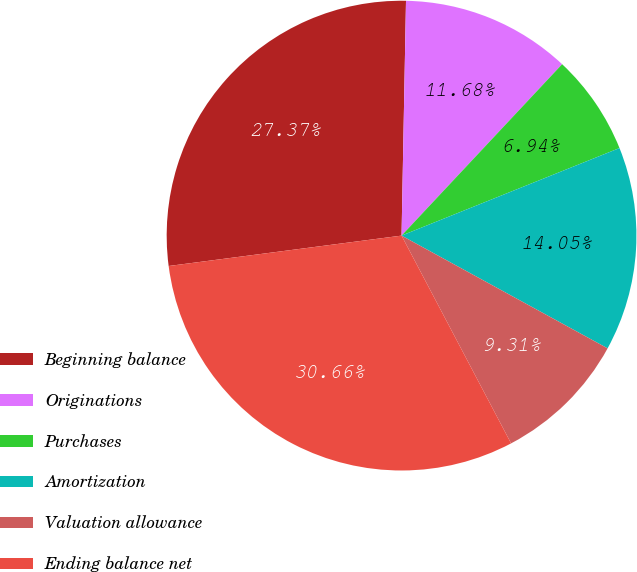<chart> <loc_0><loc_0><loc_500><loc_500><pie_chart><fcel>Beginning balance<fcel>Originations<fcel>Purchases<fcel>Amortization<fcel>Valuation allowance<fcel>Ending balance net<nl><fcel>27.37%<fcel>11.68%<fcel>6.94%<fcel>14.05%<fcel>9.31%<fcel>30.66%<nl></chart> 